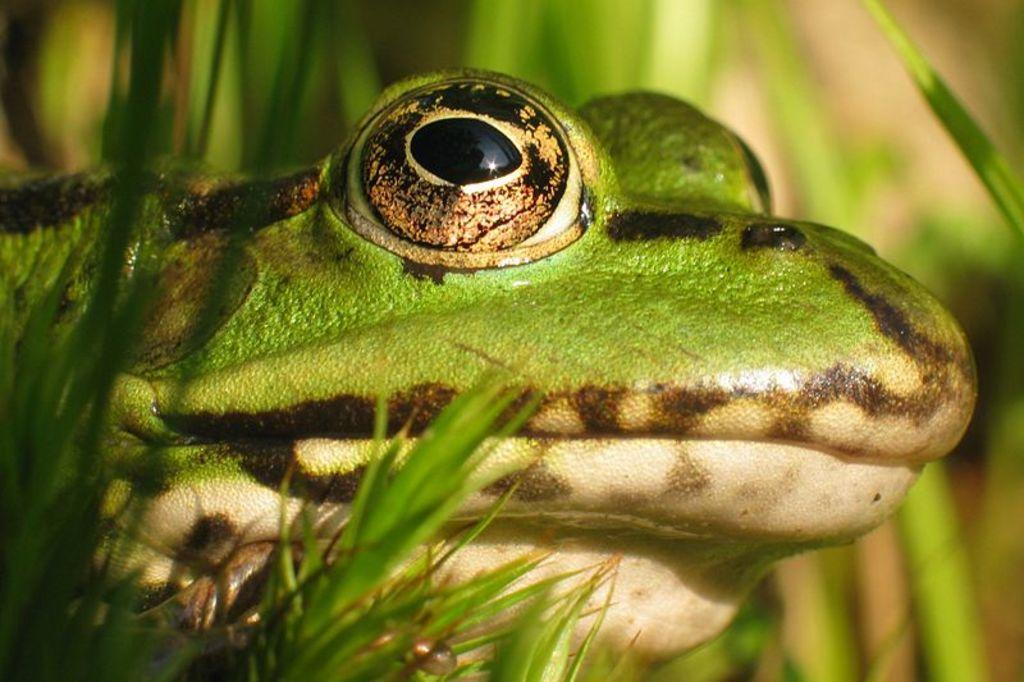What is the main subject in the foreground of the image? There is a frog in the foreground of the image. What type of vegetation can be seen in the foreground of the image? There is grass in the foreground of the image. How many brothers does the frog have in the image? There is no information about the frog's brothers in the image. Can you hear the frog whistling in the image? There is no sound in the image, so it is impossible to determine if the frog is whistling. 